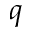Convert formula to latex. <formula><loc_0><loc_0><loc_500><loc_500>q</formula> 